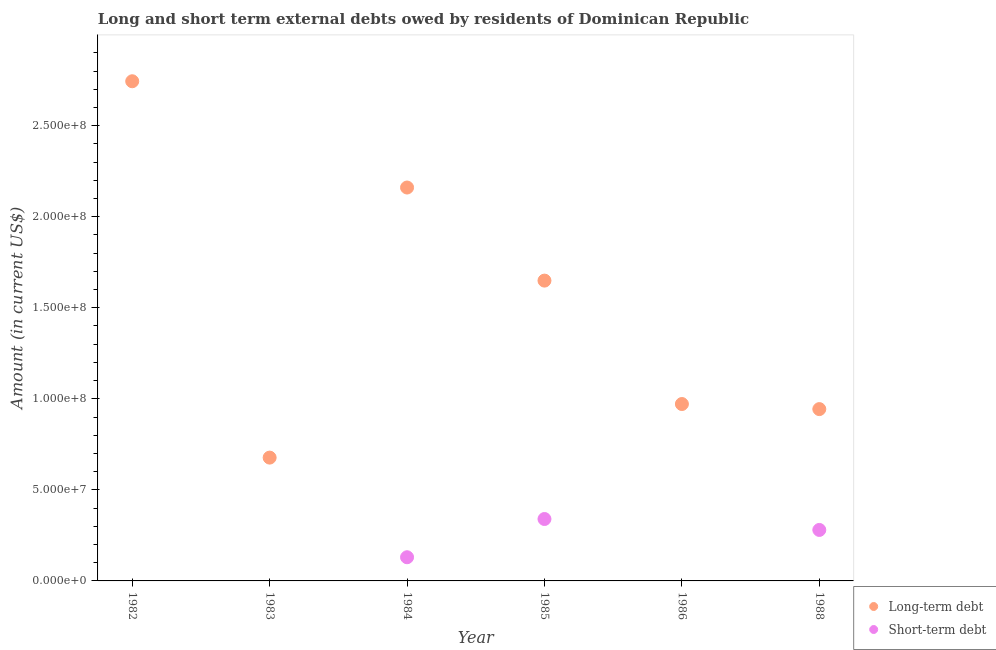What is the short-term debts owed by residents in 1984?
Offer a terse response. 1.30e+07. Across all years, what is the maximum short-term debts owed by residents?
Make the answer very short. 3.40e+07. Across all years, what is the minimum long-term debts owed by residents?
Your response must be concise. 6.77e+07. What is the total long-term debts owed by residents in the graph?
Your response must be concise. 9.15e+08. What is the difference between the short-term debts owed by residents in 1984 and that in 1988?
Make the answer very short. -1.50e+07. What is the difference between the long-term debts owed by residents in 1982 and the short-term debts owed by residents in 1986?
Provide a short and direct response. 2.74e+08. What is the average long-term debts owed by residents per year?
Offer a terse response. 1.52e+08. In the year 1985, what is the difference between the short-term debts owed by residents and long-term debts owed by residents?
Keep it short and to the point. -1.31e+08. What is the ratio of the long-term debts owed by residents in 1982 to that in 1985?
Ensure brevity in your answer.  1.66. Is the long-term debts owed by residents in 1984 less than that in 1988?
Give a very brief answer. No. What is the difference between the highest and the lowest long-term debts owed by residents?
Provide a succinct answer. 2.07e+08. In how many years, is the long-term debts owed by residents greater than the average long-term debts owed by residents taken over all years?
Provide a succinct answer. 3. Is the sum of the long-term debts owed by residents in 1984 and 1986 greater than the maximum short-term debts owed by residents across all years?
Make the answer very short. Yes. Is the short-term debts owed by residents strictly greater than the long-term debts owed by residents over the years?
Your answer should be very brief. No. Is the short-term debts owed by residents strictly less than the long-term debts owed by residents over the years?
Provide a short and direct response. Yes. How many dotlines are there?
Provide a succinct answer. 2. Does the graph contain any zero values?
Your response must be concise. Yes. Where does the legend appear in the graph?
Offer a very short reply. Bottom right. How many legend labels are there?
Your answer should be compact. 2. How are the legend labels stacked?
Keep it short and to the point. Vertical. What is the title of the graph?
Give a very brief answer. Long and short term external debts owed by residents of Dominican Republic. Does "Foreign liabilities" appear as one of the legend labels in the graph?
Offer a very short reply. No. What is the label or title of the X-axis?
Give a very brief answer. Year. What is the label or title of the Y-axis?
Your answer should be compact. Amount (in current US$). What is the Amount (in current US$) of Long-term debt in 1982?
Provide a succinct answer. 2.74e+08. What is the Amount (in current US$) of Long-term debt in 1983?
Give a very brief answer. 6.77e+07. What is the Amount (in current US$) in Long-term debt in 1984?
Give a very brief answer. 2.16e+08. What is the Amount (in current US$) in Short-term debt in 1984?
Ensure brevity in your answer.  1.30e+07. What is the Amount (in current US$) of Long-term debt in 1985?
Offer a terse response. 1.65e+08. What is the Amount (in current US$) in Short-term debt in 1985?
Your answer should be compact. 3.40e+07. What is the Amount (in current US$) of Long-term debt in 1986?
Provide a succinct answer. 9.71e+07. What is the Amount (in current US$) in Long-term debt in 1988?
Ensure brevity in your answer.  9.44e+07. What is the Amount (in current US$) in Short-term debt in 1988?
Your answer should be very brief. 2.80e+07. Across all years, what is the maximum Amount (in current US$) of Long-term debt?
Make the answer very short. 2.74e+08. Across all years, what is the maximum Amount (in current US$) of Short-term debt?
Provide a short and direct response. 3.40e+07. Across all years, what is the minimum Amount (in current US$) of Long-term debt?
Ensure brevity in your answer.  6.77e+07. What is the total Amount (in current US$) of Long-term debt in the graph?
Your answer should be very brief. 9.15e+08. What is the total Amount (in current US$) in Short-term debt in the graph?
Make the answer very short. 7.50e+07. What is the difference between the Amount (in current US$) of Long-term debt in 1982 and that in 1983?
Provide a short and direct response. 2.07e+08. What is the difference between the Amount (in current US$) in Long-term debt in 1982 and that in 1984?
Offer a terse response. 5.84e+07. What is the difference between the Amount (in current US$) in Long-term debt in 1982 and that in 1985?
Your answer should be very brief. 1.09e+08. What is the difference between the Amount (in current US$) in Long-term debt in 1982 and that in 1986?
Give a very brief answer. 1.77e+08. What is the difference between the Amount (in current US$) of Long-term debt in 1982 and that in 1988?
Offer a terse response. 1.80e+08. What is the difference between the Amount (in current US$) in Long-term debt in 1983 and that in 1984?
Offer a very short reply. -1.48e+08. What is the difference between the Amount (in current US$) in Long-term debt in 1983 and that in 1985?
Give a very brief answer. -9.72e+07. What is the difference between the Amount (in current US$) in Long-term debt in 1983 and that in 1986?
Give a very brief answer. -2.94e+07. What is the difference between the Amount (in current US$) of Long-term debt in 1983 and that in 1988?
Ensure brevity in your answer.  -2.66e+07. What is the difference between the Amount (in current US$) in Long-term debt in 1984 and that in 1985?
Provide a succinct answer. 5.11e+07. What is the difference between the Amount (in current US$) of Short-term debt in 1984 and that in 1985?
Provide a succinct answer. -2.10e+07. What is the difference between the Amount (in current US$) of Long-term debt in 1984 and that in 1986?
Keep it short and to the point. 1.19e+08. What is the difference between the Amount (in current US$) in Long-term debt in 1984 and that in 1988?
Keep it short and to the point. 1.22e+08. What is the difference between the Amount (in current US$) in Short-term debt in 1984 and that in 1988?
Your answer should be compact. -1.50e+07. What is the difference between the Amount (in current US$) in Long-term debt in 1985 and that in 1986?
Your answer should be very brief. 6.78e+07. What is the difference between the Amount (in current US$) of Long-term debt in 1985 and that in 1988?
Give a very brief answer. 7.06e+07. What is the difference between the Amount (in current US$) in Short-term debt in 1985 and that in 1988?
Offer a terse response. 6.00e+06. What is the difference between the Amount (in current US$) in Long-term debt in 1986 and that in 1988?
Offer a terse response. 2.79e+06. What is the difference between the Amount (in current US$) in Long-term debt in 1982 and the Amount (in current US$) in Short-term debt in 1984?
Offer a terse response. 2.61e+08. What is the difference between the Amount (in current US$) of Long-term debt in 1982 and the Amount (in current US$) of Short-term debt in 1985?
Offer a terse response. 2.40e+08. What is the difference between the Amount (in current US$) in Long-term debt in 1982 and the Amount (in current US$) in Short-term debt in 1988?
Provide a short and direct response. 2.46e+08. What is the difference between the Amount (in current US$) of Long-term debt in 1983 and the Amount (in current US$) of Short-term debt in 1984?
Provide a succinct answer. 5.47e+07. What is the difference between the Amount (in current US$) of Long-term debt in 1983 and the Amount (in current US$) of Short-term debt in 1985?
Provide a succinct answer. 3.37e+07. What is the difference between the Amount (in current US$) in Long-term debt in 1983 and the Amount (in current US$) in Short-term debt in 1988?
Offer a terse response. 3.97e+07. What is the difference between the Amount (in current US$) of Long-term debt in 1984 and the Amount (in current US$) of Short-term debt in 1985?
Provide a succinct answer. 1.82e+08. What is the difference between the Amount (in current US$) in Long-term debt in 1984 and the Amount (in current US$) in Short-term debt in 1988?
Provide a succinct answer. 1.88e+08. What is the difference between the Amount (in current US$) in Long-term debt in 1985 and the Amount (in current US$) in Short-term debt in 1988?
Give a very brief answer. 1.37e+08. What is the difference between the Amount (in current US$) of Long-term debt in 1986 and the Amount (in current US$) of Short-term debt in 1988?
Provide a short and direct response. 6.91e+07. What is the average Amount (in current US$) of Long-term debt per year?
Your response must be concise. 1.52e+08. What is the average Amount (in current US$) in Short-term debt per year?
Your answer should be compact. 1.25e+07. In the year 1984, what is the difference between the Amount (in current US$) in Long-term debt and Amount (in current US$) in Short-term debt?
Provide a succinct answer. 2.03e+08. In the year 1985, what is the difference between the Amount (in current US$) in Long-term debt and Amount (in current US$) in Short-term debt?
Provide a short and direct response. 1.31e+08. In the year 1988, what is the difference between the Amount (in current US$) in Long-term debt and Amount (in current US$) in Short-term debt?
Offer a terse response. 6.64e+07. What is the ratio of the Amount (in current US$) in Long-term debt in 1982 to that in 1983?
Your answer should be compact. 4.05. What is the ratio of the Amount (in current US$) in Long-term debt in 1982 to that in 1984?
Provide a short and direct response. 1.27. What is the ratio of the Amount (in current US$) of Long-term debt in 1982 to that in 1985?
Provide a short and direct response. 1.66. What is the ratio of the Amount (in current US$) in Long-term debt in 1982 to that in 1986?
Make the answer very short. 2.82. What is the ratio of the Amount (in current US$) in Long-term debt in 1982 to that in 1988?
Your answer should be compact. 2.91. What is the ratio of the Amount (in current US$) in Long-term debt in 1983 to that in 1984?
Provide a succinct answer. 0.31. What is the ratio of the Amount (in current US$) in Long-term debt in 1983 to that in 1985?
Provide a short and direct response. 0.41. What is the ratio of the Amount (in current US$) of Long-term debt in 1983 to that in 1986?
Give a very brief answer. 0.7. What is the ratio of the Amount (in current US$) in Long-term debt in 1983 to that in 1988?
Your answer should be compact. 0.72. What is the ratio of the Amount (in current US$) in Long-term debt in 1984 to that in 1985?
Offer a terse response. 1.31. What is the ratio of the Amount (in current US$) in Short-term debt in 1984 to that in 1985?
Give a very brief answer. 0.38. What is the ratio of the Amount (in current US$) of Long-term debt in 1984 to that in 1986?
Give a very brief answer. 2.22. What is the ratio of the Amount (in current US$) in Long-term debt in 1984 to that in 1988?
Provide a succinct answer. 2.29. What is the ratio of the Amount (in current US$) in Short-term debt in 1984 to that in 1988?
Make the answer very short. 0.46. What is the ratio of the Amount (in current US$) in Long-term debt in 1985 to that in 1986?
Keep it short and to the point. 1.7. What is the ratio of the Amount (in current US$) in Long-term debt in 1985 to that in 1988?
Keep it short and to the point. 1.75. What is the ratio of the Amount (in current US$) of Short-term debt in 1985 to that in 1988?
Ensure brevity in your answer.  1.21. What is the ratio of the Amount (in current US$) in Long-term debt in 1986 to that in 1988?
Make the answer very short. 1.03. What is the difference between the highest and the second highest Amount (in current US$) in Long-term debt?
Provide a succinct answer. 5.84e+07. What is the difference between the highest and the lowest Amount (in current US$) of Long-term debt?
Offer a very short reply. 2.07e+08. What is the difference between the highest and the lowest Amount (in current US$) in Short-term debt?
Give a very brief answer. 3.40e+07. 